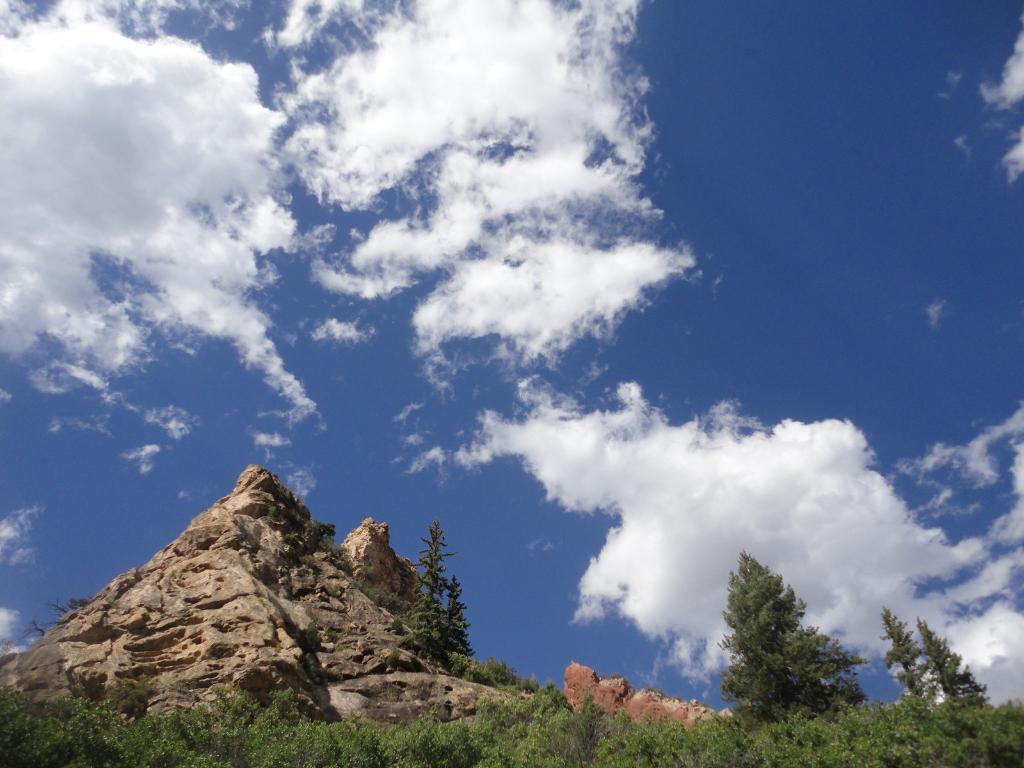What type of landscape feature is present in the image? There is a hill in the image. What other natural elements can be seen in the image? There are trees in the image. What is visible in the background of the image? The sky is visible in the image. What can be observed in the sky? Clouds are present in the sky. Where is the tray located in the image? There is no tray present in the image. Can you see a chess game being played on the hill in the image? There is no chess game visible in the image. 